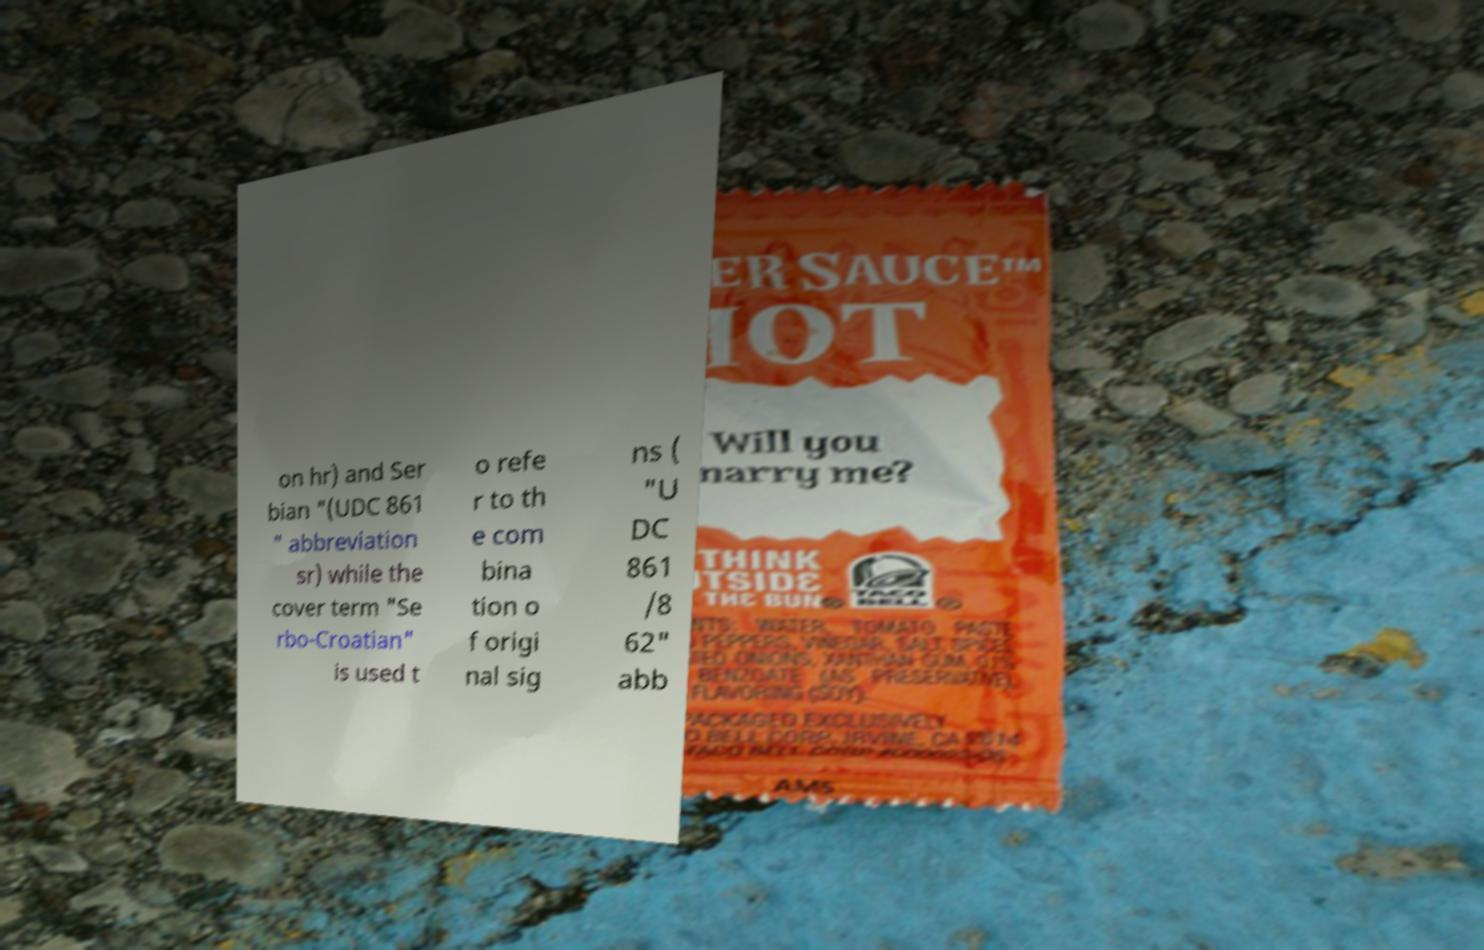Could you extract and type out the text from this image? on hr) and Ser bian "(UDC 861 " abbreviation sr) while the cover term "Se rbo-Croatian" is used t o refe r to th e com bina tion o f origi nal sig ns ( "U DC 861 /8 62" abb 